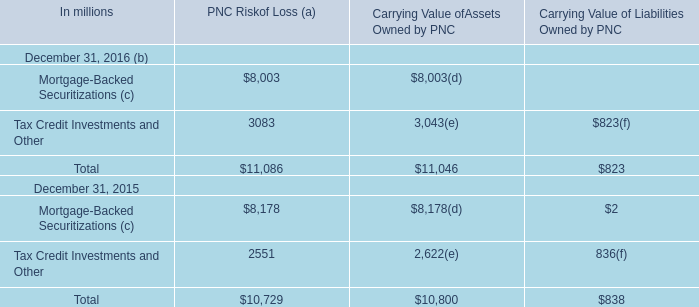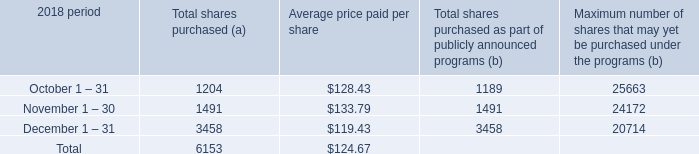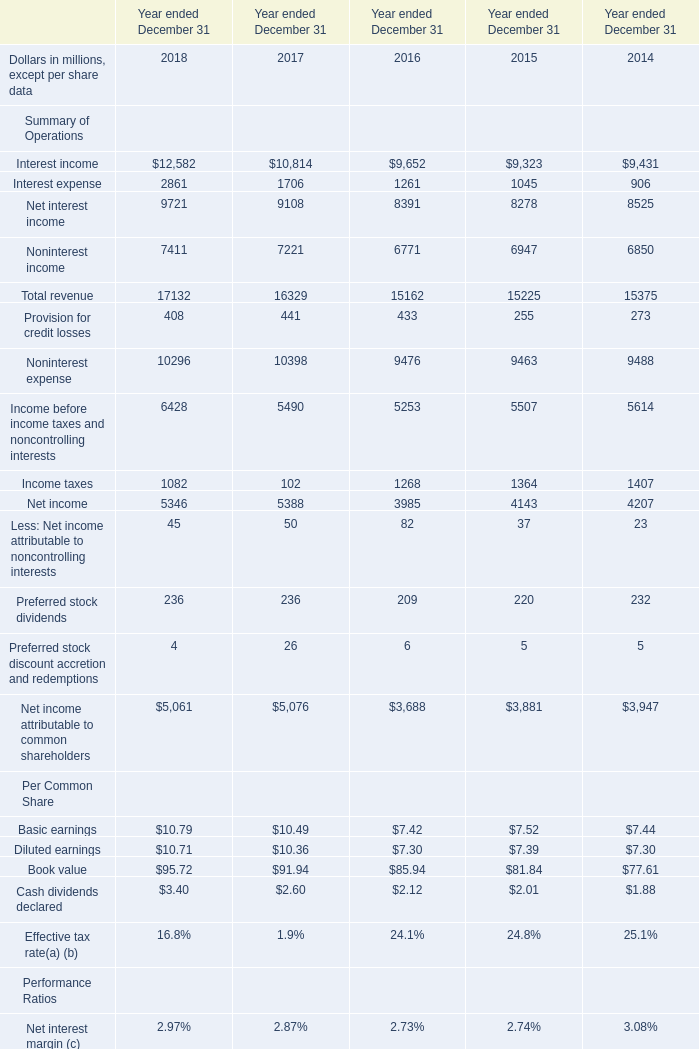What's the average of the Total revenue for Summary of Operations in the years where Mortgage-Backed Securitizations (c) for PNC Riskof Loss (a) is positive? (in million) 
Computations: ((15162 + 15225) / 2)
Answer: 15193.5. 